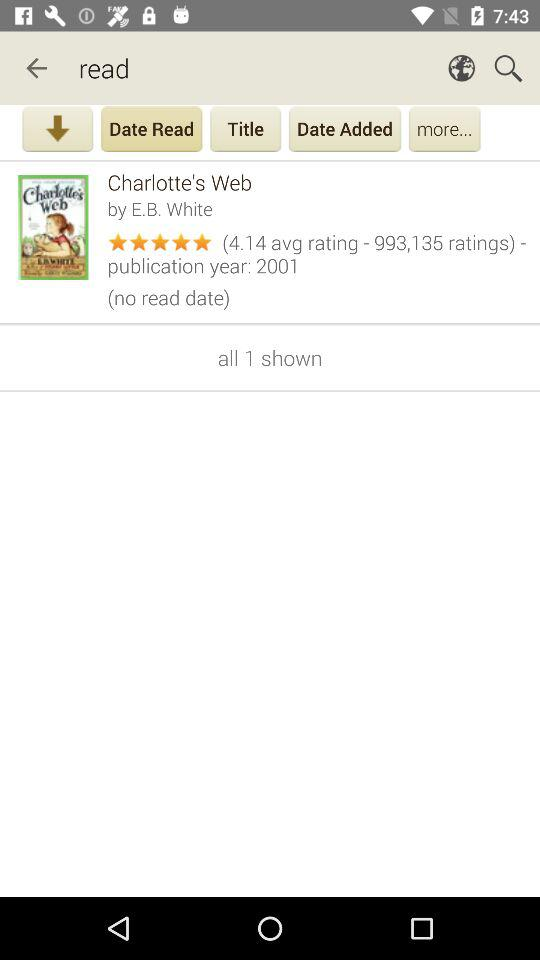How many stars are given to Charlotte's Web? There are 5 stars given to Charlotte's Web. 